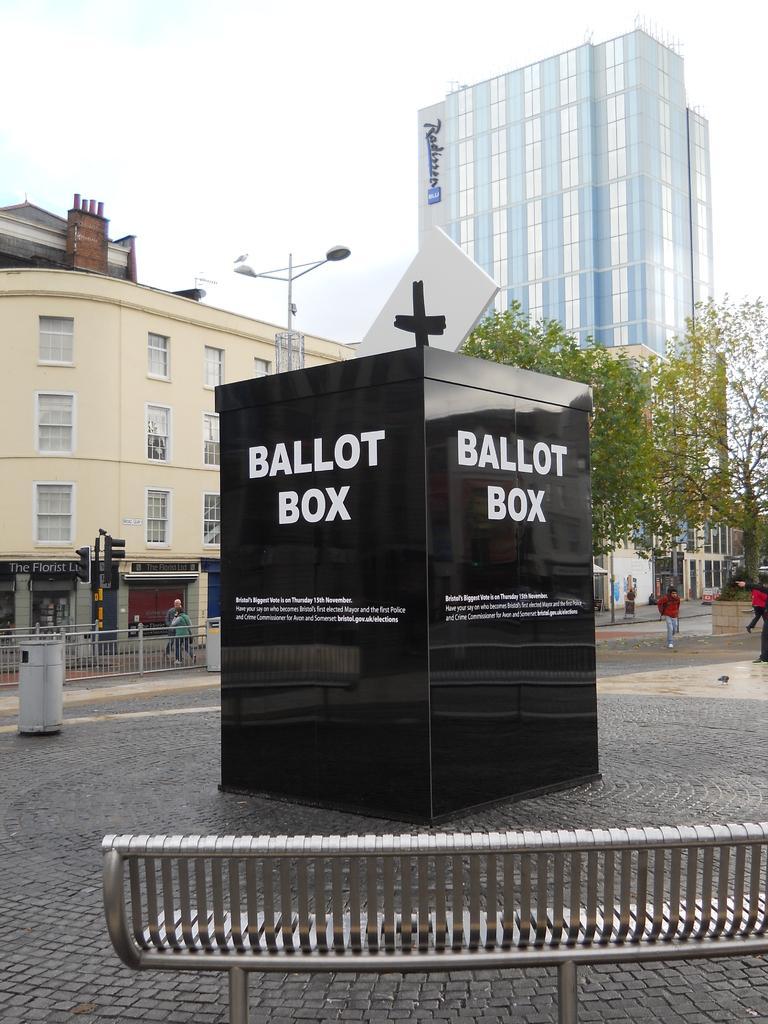Describe this image in one or two sentences. In the center of the image there is a black color structure with some text on it. In the foreground of the image there is a bench. At the bottom of the image there is floor. In the background of the image there are buildings, trees, people walking. At the top of the image there is sky. 